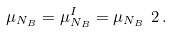<formula> <loc_0><loc_0><loc_500><loc_500>\mu _ { N _ { B } } = \mu _ { N _ { B } } ^ { I } = \mu _ { N _ { B } } \ 2 \, .</formula> 